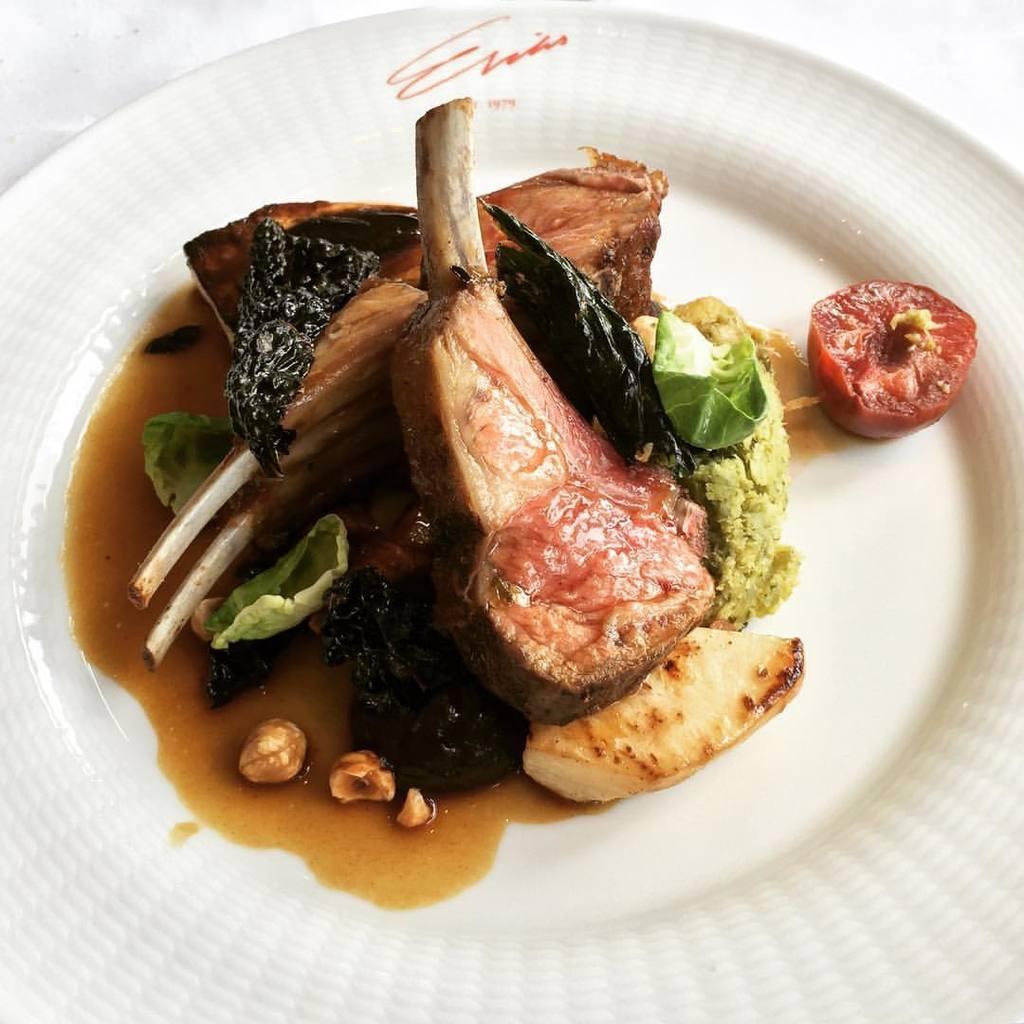Please provide a concise description of this image. In the middle of this image, there are food items arranged on a white color plate. This plate is placed on a surface. And the background is white in color. 